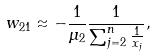<formula> <loc_0><loc_0><loc_500><loc_500>w _ { 2 1 } \approx - \frac { 1 } { \mu _ { 2 } } \frac { 1 } { \sum _ { j = 2 } ^ { n } \frac { 1 } { x _ { j } } } ,</formula> 